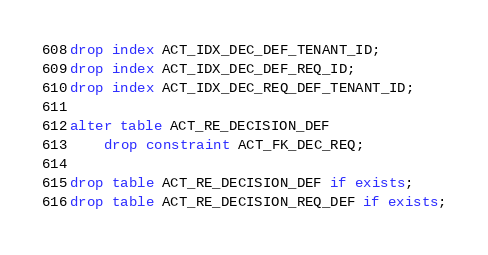<code> <loc_0><loc_0><loc_500><loc_500><_SQL_>drop index ACT_IDX_DEC_DEF_TENANT_ID;
drop index ACT_IDX_DEC_DEF_REQ_ID;
drop index ACT_IDX_DEC_REQ_DEF_TENANT_ID;

alter table ACT_RE_DECISION_DEF
    drop constraint ACT_FK_DEC_REQ;

drop table ACT_RE_DECISION_DEF if exists;
drop table ACT_RE_DECISION_REQ_DEF if exists;
</code> 